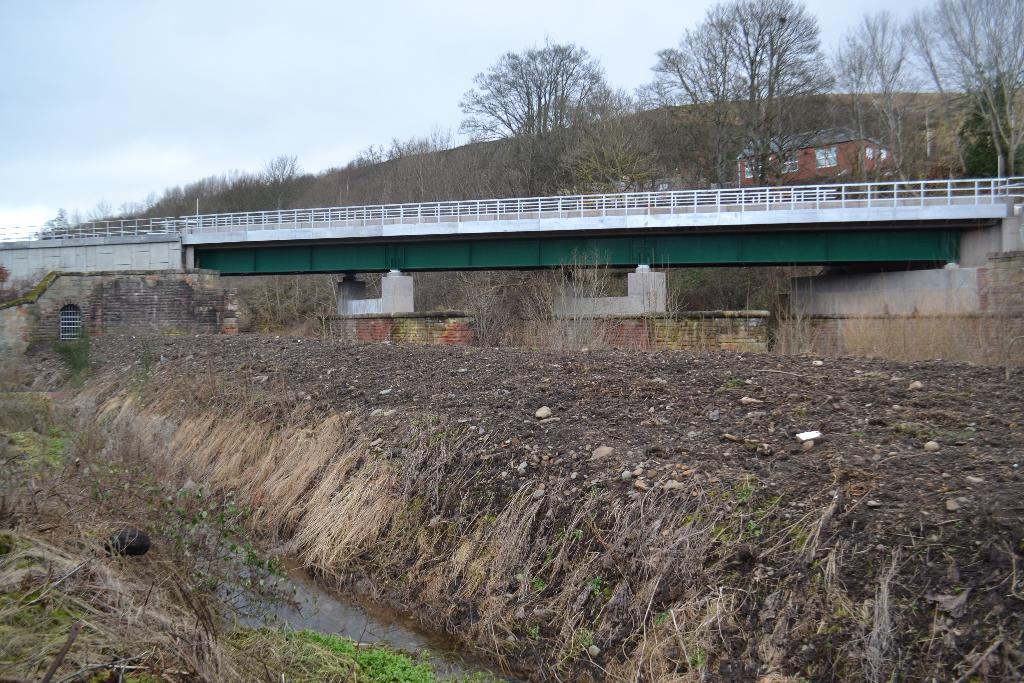What type of terrain is visible in the image? There is land in the image. What structure can be seen in the background of the image? There is a bridge in the background of the image. What other natural elements are present in the background of the image? There are trees, a house, and a mountain in the background of the image. How would you describe the sky in the image? The sky is cloudy in the image. What type of chin can be seen on the mountain in the image? There is no chin present in the image, as it features a landscape with a mountain, not a person. 